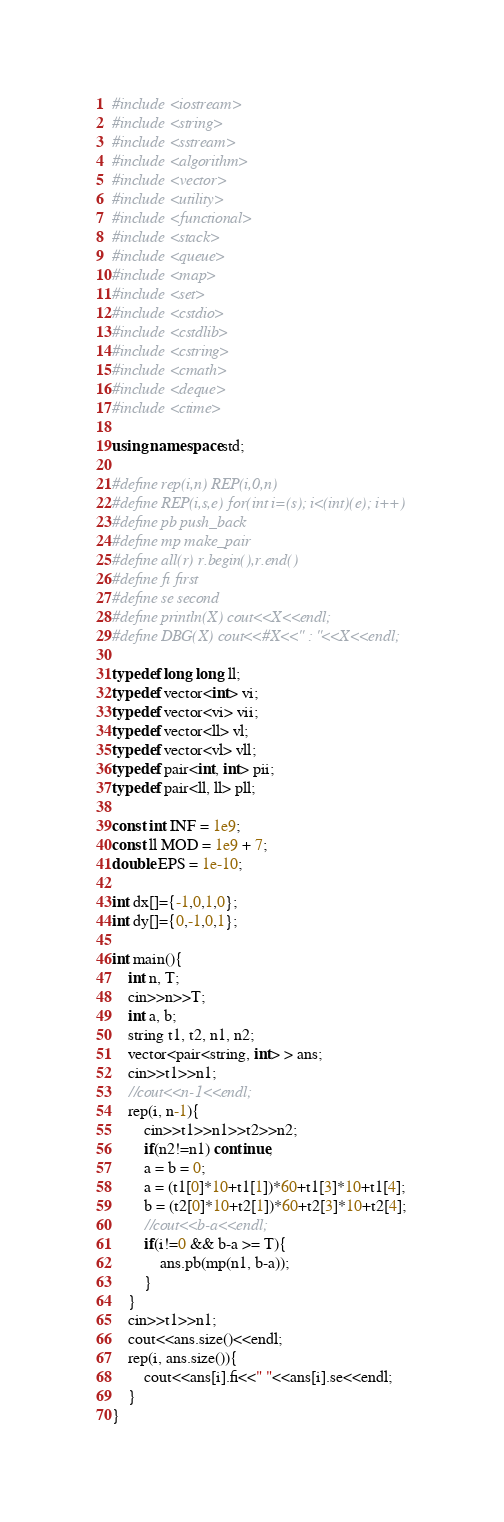Convert code to text. <code><loc_0><loc_0><loc_500><loc_500><_C++_>#include <iostream>
#include <string>
#include <sstream>
#include <algorithm>
#include <vector>
#include <utility>
#include <functional>
#include <stack>
#include <queue>
#include <map>
#include <set>
#include <cstdio>
#include <cstdlib>
#include <cstring>
#include <cmath>
#include <deque>
#include <ctime>
 
using namespace std;
 
#define rep(i,n) REP(i,0,n)
#define REP(i,s,e) for(int i=(s); i<(int)(e); i++)
#define pb push_back
#define mp make_pair
#define all(r) r.begin(),r.end()
#define fi first
#define se second
#define println(X) cout<<X<<endl;
#define DBG(X) cout<<#X<<" : "<<X<<endl;
 
typedef long long ll;
typedef vector<int> vi;
typedef vector<vi> vii;
typedef vector<ll> vl;
typedef vector<vl> vll;
typedef pair<int, int> pii;
typedef pair<ll, ll> pll;

const int INF = 1e9;
const ll MOD = 1e9 + 7;
double EPS = 1e-10;

int dx[]={-1,0,1,0};
int dy[]={0,-1,0,1};

int main(){
	int n, T;
	cin>>n>>T;
	int a, b;
	string t1, t2, n1, n2;
	vector<pair<string, int> > ans;
	cin>>t1>>n1;
	//cout<<n-1<<endl;
	rep(i, n-1){
		cin>>t1>>n1>>t2>>n2;
		if(n2!=n1) continue;
		a = b = 0;
		a = (t1[0]*10+t1[1])*60+t1[3]*10+t1[4];
		b = (t2[0]*10+t2[1])*60+t2[3]*10+t2[4];
		//cout<<b-a<<endl;
		if(i!=0 && b-a >= T){
			ans.pb(mp(n1, b-a));
		}
	}
	cin>>t1>>n1;
	cout<<ans.size()<<endl;
	rep(i, ans.size()){
		cout<<ans[i].fi<<" "<<ans[i].se<<endl;
	}
}</code> 